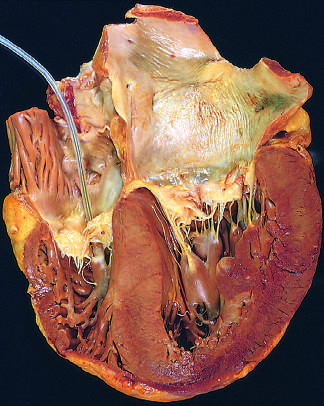s there marked concentric thickening of the left ventricular wall causing reduction in lumen size?
Answer the question using a single word or phrase. Yes 